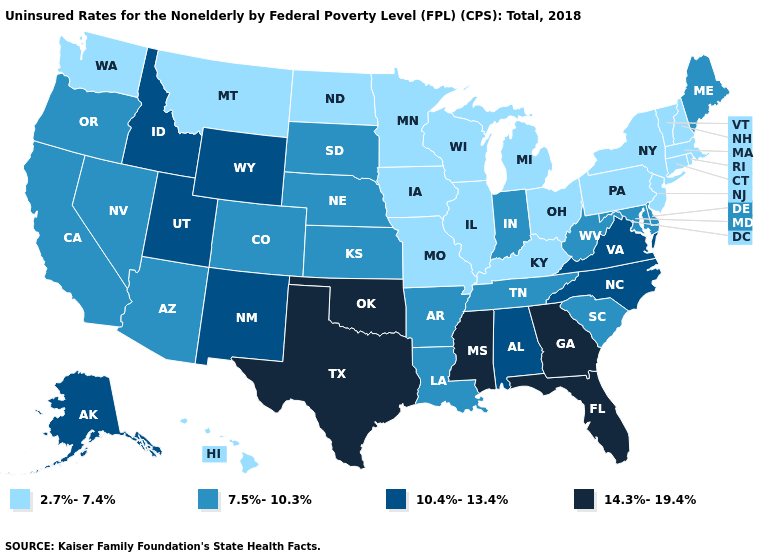Name the states that have a value in the range 10.4%-13.4%?
Answer briefly. Alabama, Alaska, Idaho, New Mexico, North Carolina, Utah, Virginia, Wyoming. What is the highest value in the West ?
Write a very short answer. 10.4%-13.4%. Which states have the lowest value in the USA?
Answer briefly. Connecticut, Hawaii, Illinois, Iowa, Kentucky, Massachusetts, Michigan, Minnesota, Missouri, Montana, New Hampshire, New Jersey, New York, North Dakota, Ohio, Pennsylvania, Rhode Island, Vermont, Washington, Wisconsin. Does Rhode Island have the lowest value in the Northeast?
Be succinct. Yes. Is the legend a continuous bar?
Short answer required. No. Which states have the lowest value in the West?
Write a very short answer. Hawaii, Montana, Washington. Among the states that border Oregon , which have the highest value?
Short answer required. Idaho. Does the first symbol in the legend represent the smallest category?
Concise answer only. Yes. What is the highest value in the USA?
Keep it brief. 14.3%-19.4%. What is the highest value in the USA?
Be succinct. 14.3%-19.4%. Name the states that have a value in the range 14.3%-19.4%?
Keep it brief. Florida, Georgia, Mississippi, Oklahoma, Texas. Name the states that have a value in the range 7.5%-10.3%?
Be succinct. Arizona, Arkansas, California, Colorado, Delaware, Indiana, Kansas, Louisiana, Maine, Maryland, Nebraska, Nevada, Oregon, South Carolina, South Dakota, Tennessee, West Virginia. Does the first symbol in the legend represent the smallest category?
Give a very brief answer. Yes. What is the value of Georgia?
Give a very brief answer. 14.3%-19.4%. Among the states that border Alabama , which have the highest value?
Write a very short answer. Florida, Georgia, Mississippi. 